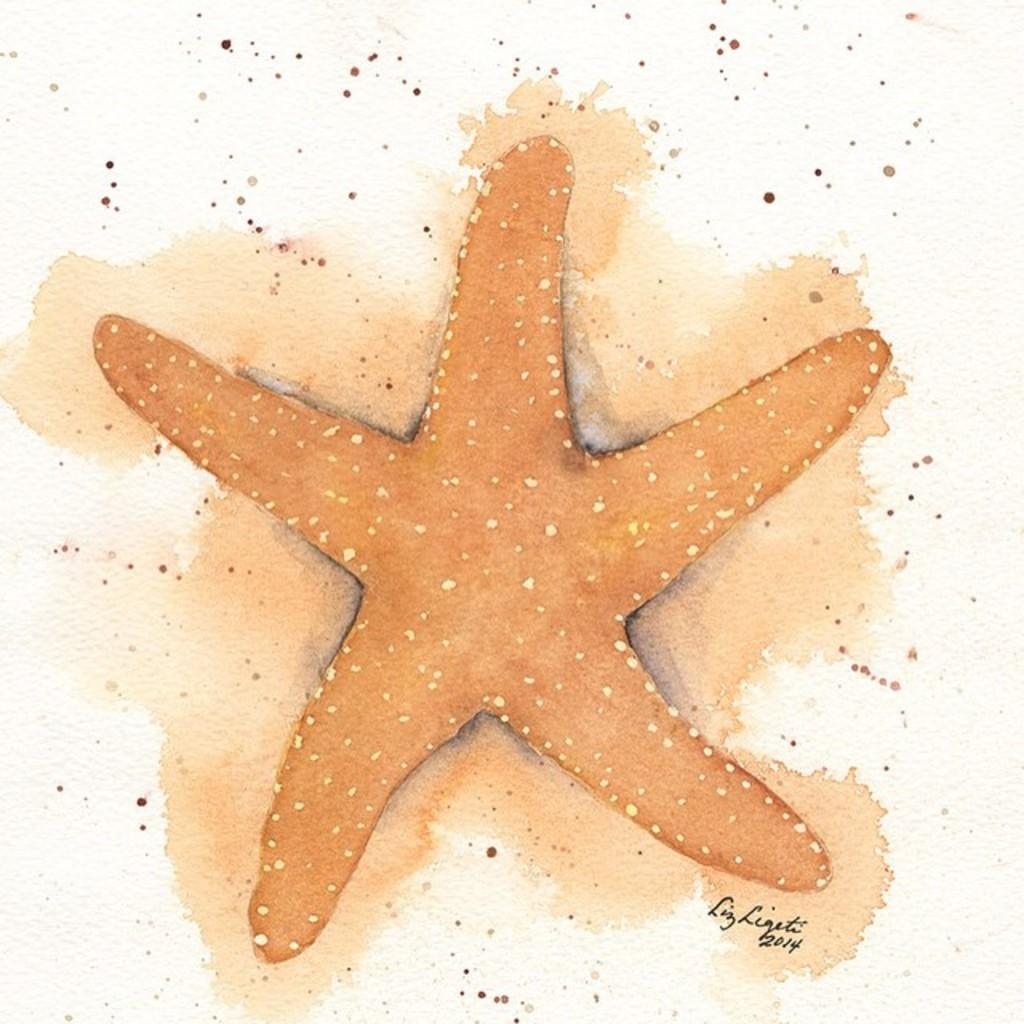What type of artwork is depicted in the image? The image is a painting. What is the main subject of the painting? There is a starfish in the painting. Is there any text present in the painting? Yes, there is text at the bottom of the painting. What color is the background of the painting? A: The background of the painting is white. What additional design elements can be seen on the white background? There are red dots on the white background. What type of verse is being recited by the quince in the painting? There is no quince present in the painting, and therefore no verse can be recited by it. 